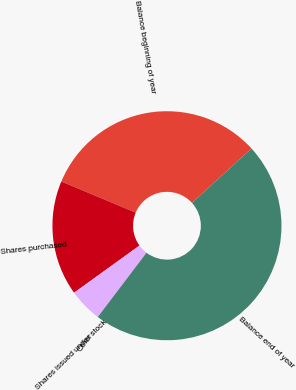Convert chart to OTSL. <chart><loc_0><loc_0><loc_500><loc_500><pie_chart><fcel>Balance beginning of year<fcel>Shares purchased<fcel>Shares issued under stock<fcel>Other<fcel>Balance end of year<nl><fcel>31.9%<fcel>16.26%<fcel>4.72%<fcel>0.01%<fcel>47.11%<nl></chart> 